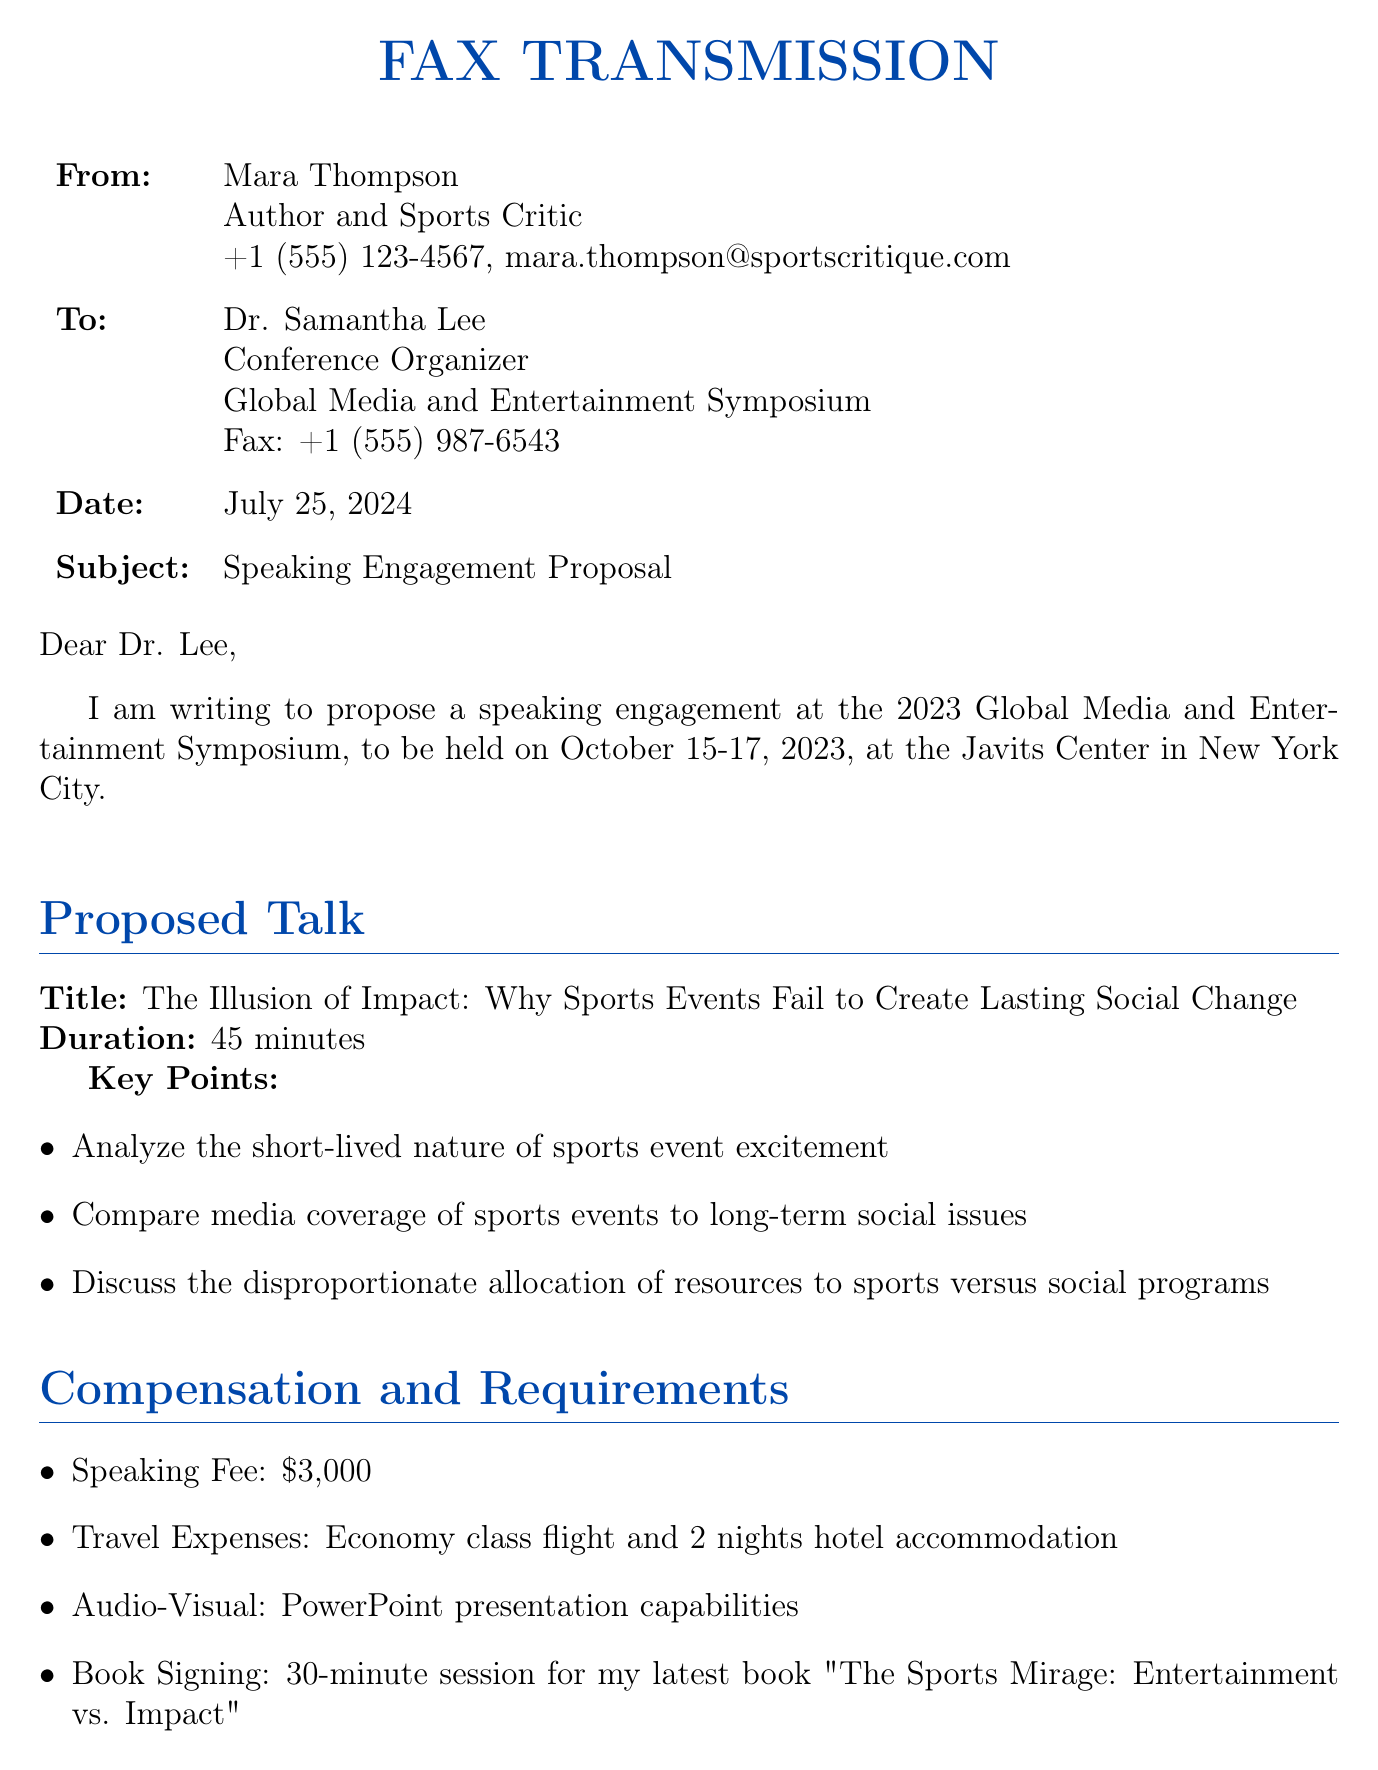What is the sender's name? The sender's name is mentioned at the beginning of the document, in the "From" section.
Answer: Mara Thompson What is the proposed talk title? The proposed talk title is clearly stated in the "Proposed Talk" section.
Answer: The Illusion of Impact: Why Sports Events Fail to Create Lasting Social Change What is the speaking fee amount? The speaking fee is listed under "Compensation and Requirements."
Answer: $3,000 Where is the conference being held? The location of the conference is indicated in the introduction of the fax.
Answer: Javits Center in New York City How long is the proposed talk? The duration is specified in the "Proposed Talk" section.
Answer: 45 minutes What is the date of the conference? The date is clearly mentioned in the opening paragraph of the fax.
Answer: October 15-17, 2023 What resources are allocated to sports events compared to social programs? This information can be inferred from the key points of the proposed talk, which compares the allocation of resources.
Answer: Disproportionate allocation of resources What follow-up activity is mentioned after the talk? The document specifies an additional activity after the proposed talk.
Answer: Book Signing What kind of presentation capabilities are required? The requirements for audio-visual capabilities are stated in the "Compensation and Requirements" section.
Answer: PowerPoint presentation capabilities 